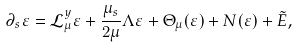<formula> <loc_0><loc_0><loc_500><loc_500>\partial _ { s } \varepsilon & = { \mathcal { L } _ { \mu } ^ { y } } \varepsilon + \frac { \mu _ { s } } { 2 \mu } \Lambda \varepsilon + \Theta _ { \mu } ( \varepsilon ) + N ( \varepsilon ) + \tilde { E } ,</formula> 